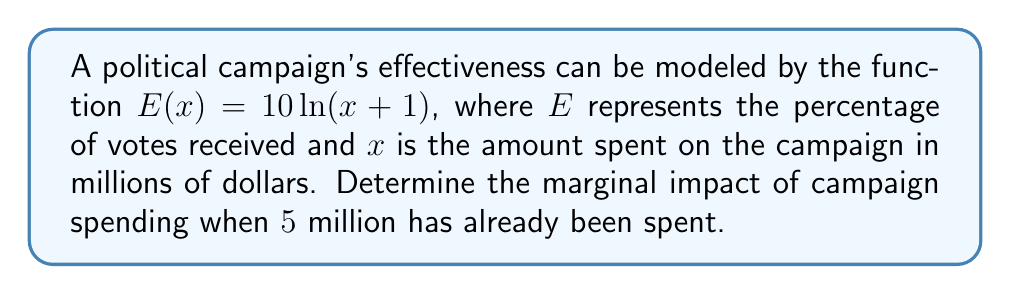Give your solution to this math problem. To find the marginal impact of campaign spending, we need to calculate the derivative of the given function and evaluate it at the specified point.

1. The given function is $E(x) = 10\ln(x+1)$

2. To find the derivative, we use the chain rule:
   $$\frac{dE}{dx} = 10 \cdot \frac{d}{dx}[\ln(x+1)]$$

3. The derivative of $\ln(x)$ is $\frac{1}{x}$, so:
   $$\frac{dE}{dx} = 10 \cdot \frac{1}{x+1}$$

4. Simplify:
   $$E'(x) = \frac{10}{x+1}$$

5. Now, we need to evaluate this at $x = 5$ (since $5 million has already been spent):
   $$E'(5) = \frac{10}{5+1} = \frac{10}{6} = \frac{5}{3} \approx 1.67$$

This means that when $5 million has been spent, each additional million dollars spent on the campaign is expected to increase the vote percentage by approximately 1.67%.
Answer: $\frac{5}{3}$ or approximately 1.67% 